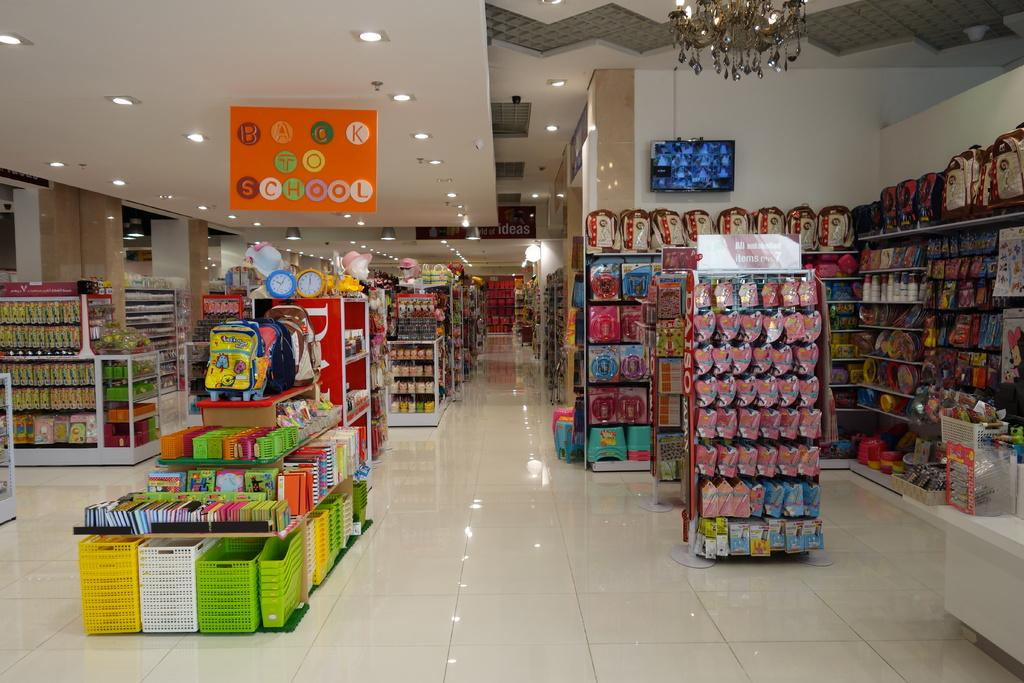Provide a one-sentence caption for the provided image. A store with displays and a sign above them saying "Back to School.". 